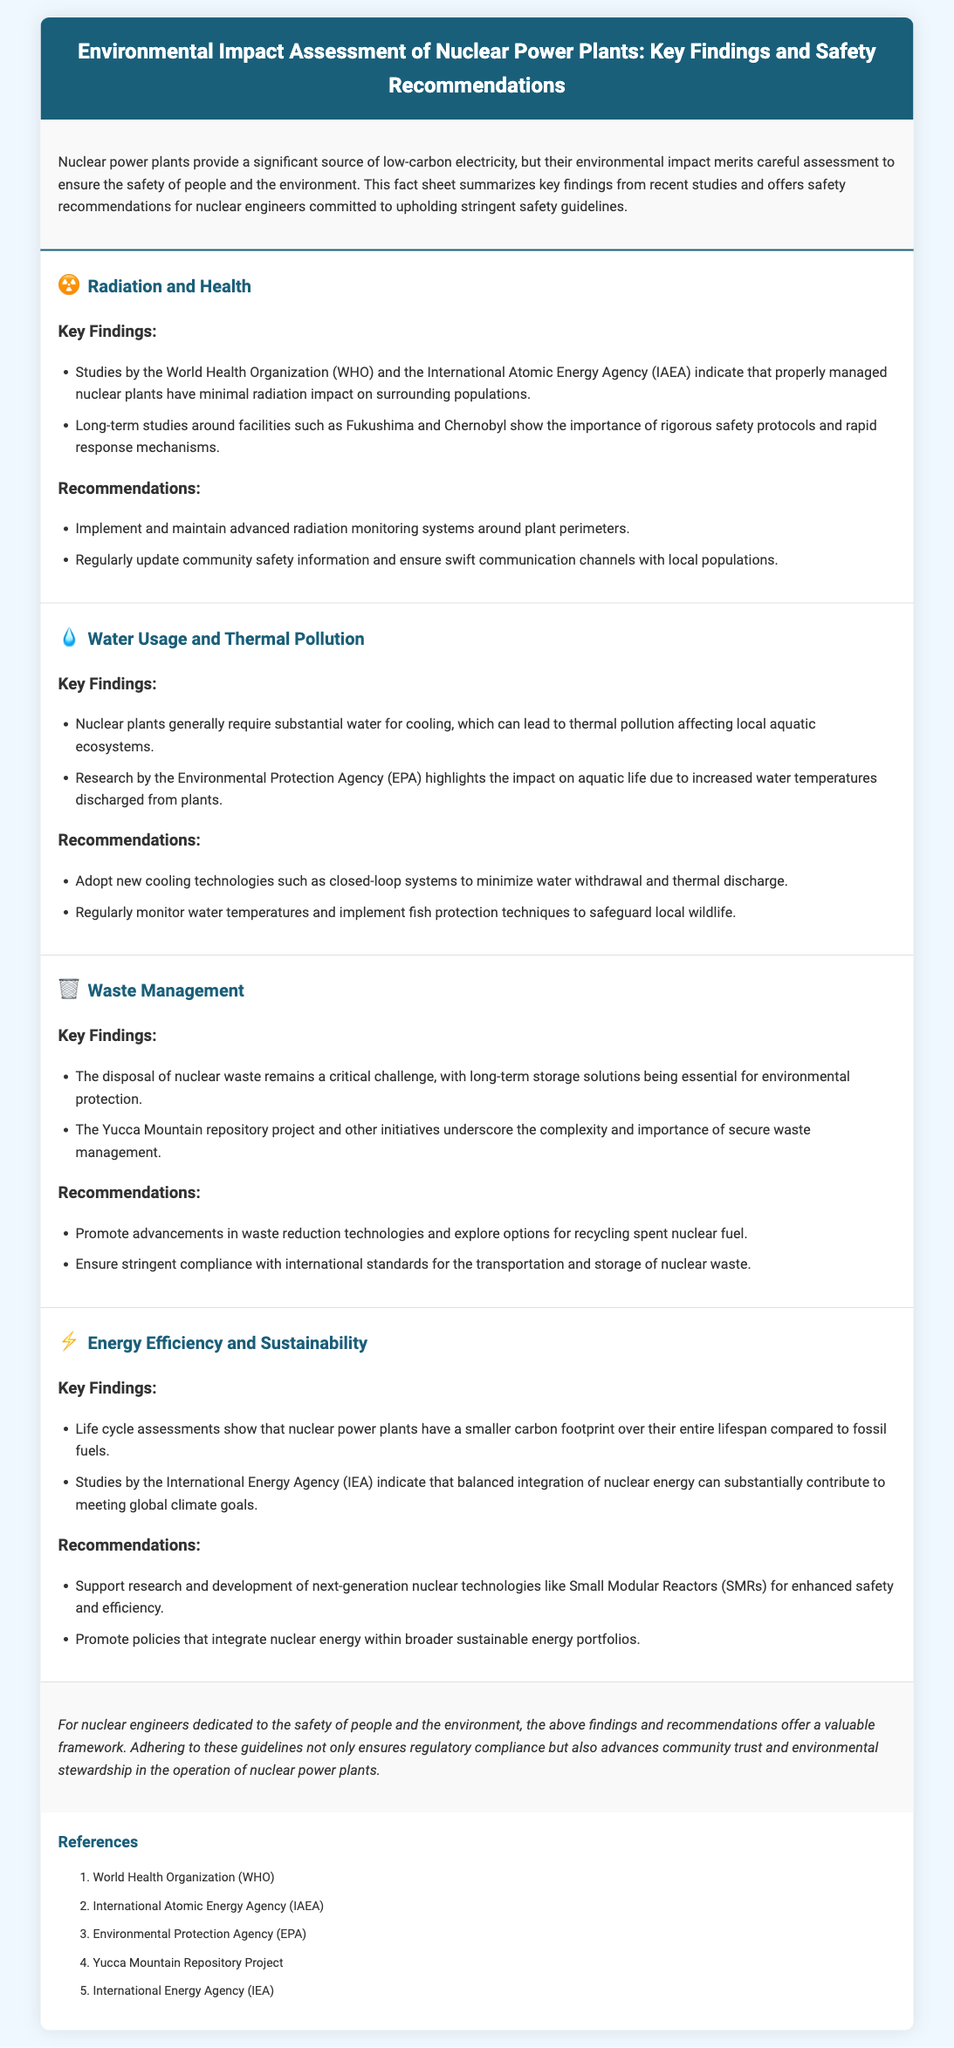What organizations conducted studies on radiation impact? The studies on radiation impact were conducted by the World Health Organization (WHO) and the International Atomic Energy Agency (IAEA).
Answer: WHO and IAEA What is a key finding about thermal pollution? A key finding is that nuclear plants require substantial water for cooling, leading to thermal pollution affecting local aquatic ecosystems.
Answer: Thermal pollution affecting local aquatic ecosystems What is the critical challenge in waste management? The disposal of nuclear waste remains a critical challenge, with long-term storage solutions being essential for environmental protection.
Answer: Disposal of nuclear waste What technology should nuclear plants adopt for water usage? Nuclear plants should adopt new cooling technologies such as closed-loop systems to minimize water withdrawal and thermal discharge.
Answer: Closed-loop systems What is a recommendation for radiation monitoring? A recommendation is to implement and maintain advanced radiation monitoring systems around plant perimeters.
Answer: Advanced radiation monitoring systems How do life cycle assessments compare nuclear power and fossil fuels? Life cycle assessments show that nuclear power plants have a smaller carbon footprint over their entire lifespan compared to fossil fuels.
Answer: Smaller carbon footprint What do studies by the International Energy Agency highlight? Studies by the International Energy Agency indicate that balanced integration of nuclear energy can substantially contribute to meeting global climate goals.
Answer: Contribute to meeting global climate goals What is the conclusion of the fact sheet? The conclusion offers a framework for nuclear engineers to ensure safety and advance community trust and environmental stewardship.
Answer: Framework for safety and stewardship 